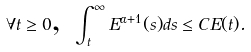Convert formula to latex. <formula><loc_0><loc_0><loc_500><loc_500>\forall t \geq 0 \text {, } \int _ { t } ^ { \infty } E ^ { \alpha + 1 } ( s ) d s \leq C E ( t ) .</formula> 